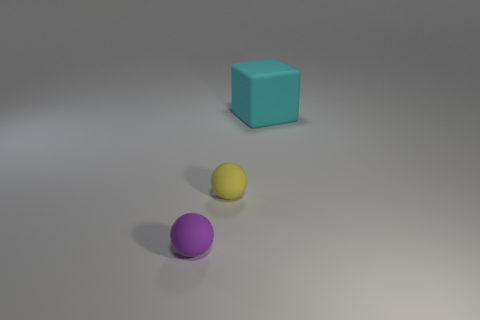Subtract 1 spheres. How many spheres are left? 1 Add 3 matte things. How many objects exist? 6 Subtract all spheres. How many objects are left? 1 Subtract all large green metallic spheres. Subtract all big blocks. How many objects are left? 2 Add 3 yellow balls. How many yellow balls are left? 4 Add 2 tiny spheres. How many tiny spheres exist? 4 Subtract 1 yellow balls. How many objects are left? 2 Subtract all cyan spheres. Subtract all purple cylinders. How many spheres are left? 2 Subtract all cyan cylinders. How many green spheres are left? 0 